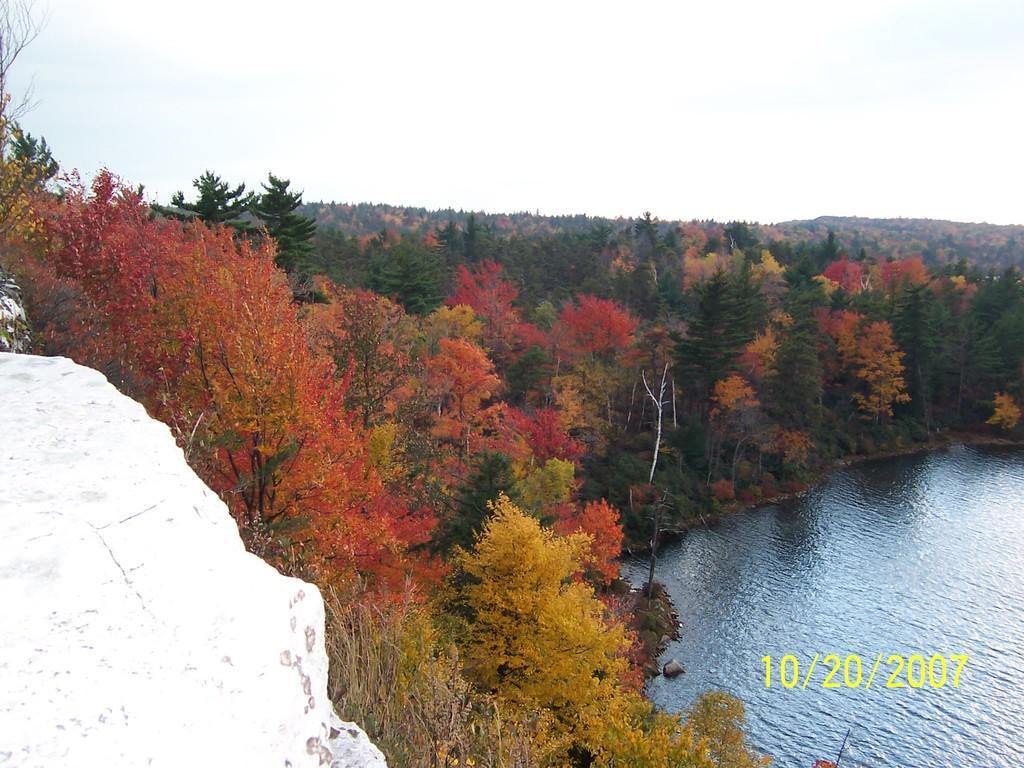Describe this image in one or two sentences. In the image there are many trees with different colors. At the right side of the image there is water and also there is a date at the right side of the image. At the top of the image there is a sky with clouds. 